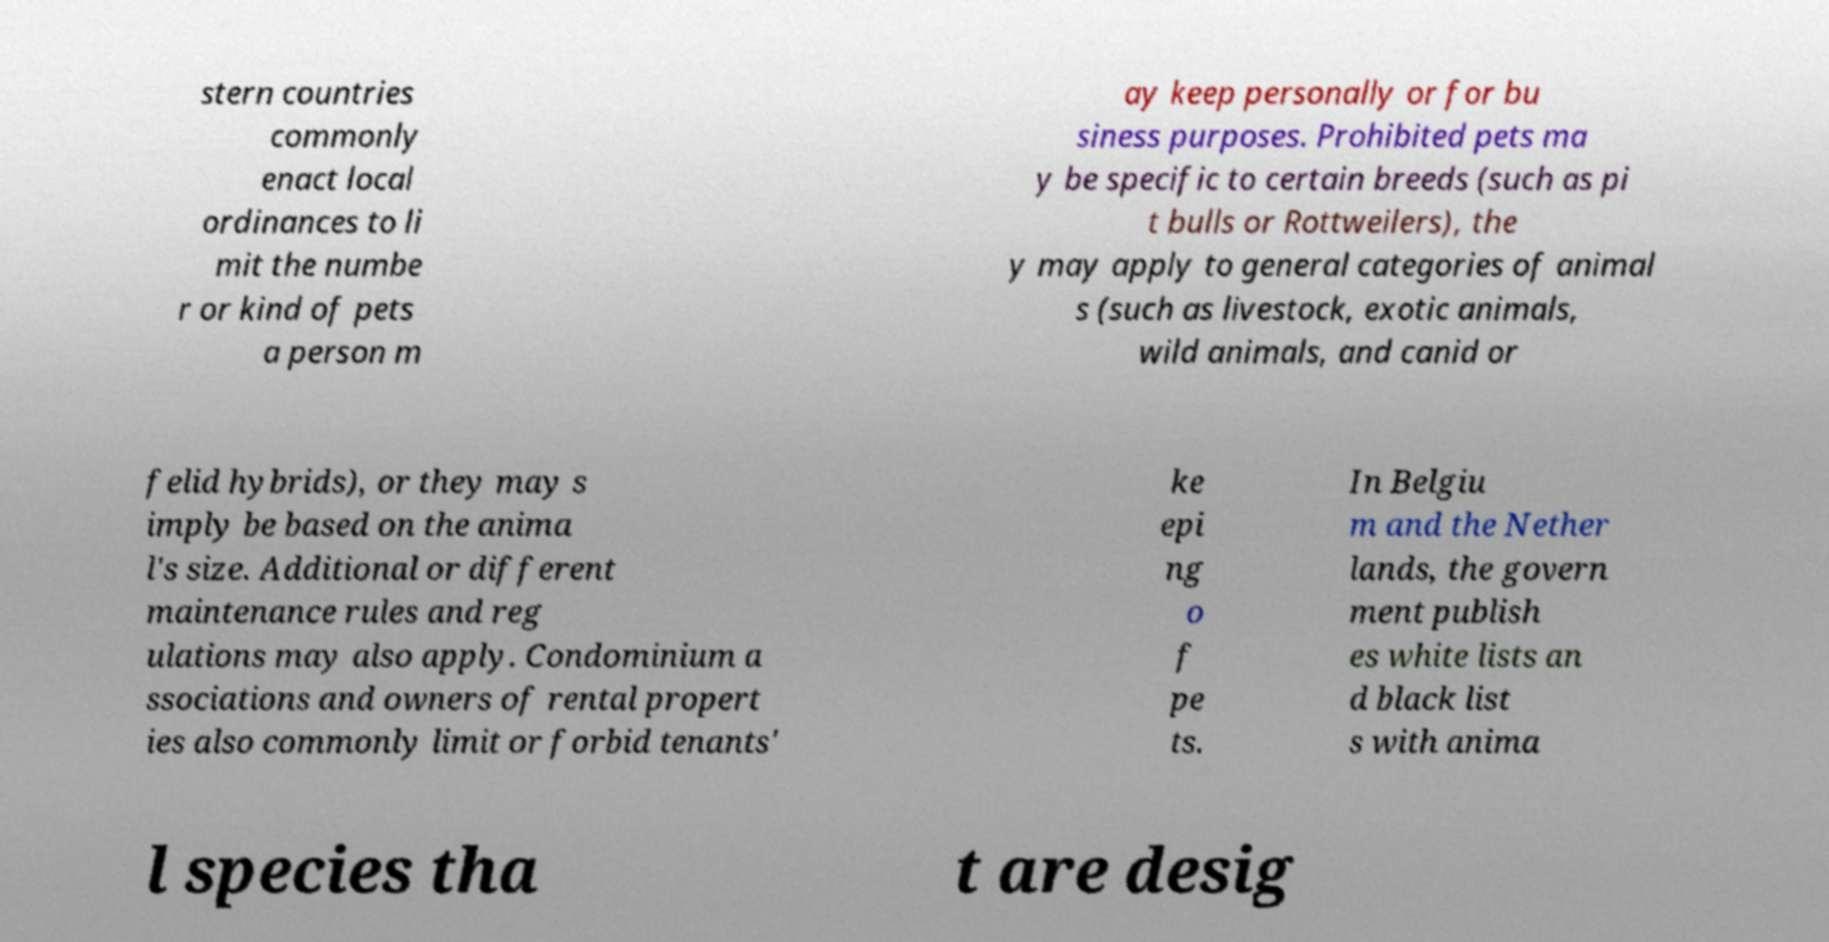Can you accurately transcribe the text from the provided image for me? stern countries commonly enact local ordinances to li mit the numbe r or kind of pets a person m ay keep personally or for bu siness purposes. Prohibited pets ma y be specific to certain breeds (such as pi t bulls or Rottweilers), the y may apply to general categories of animal s (such as livestock, exotic animals, wild animals, and canid or felid hybrids), or they may s imply be based on the anima l's size. Additional or different maintenance rules and reg ulations may also apply. Condominium a ssociations and owners of rental propert ies also commonly limit or forbid tenants' ke epi ng o f pe ts. In Belgiu m and the Nether lands, the govern ment publish es white lists an d black list s with anima l species tha t are desig 